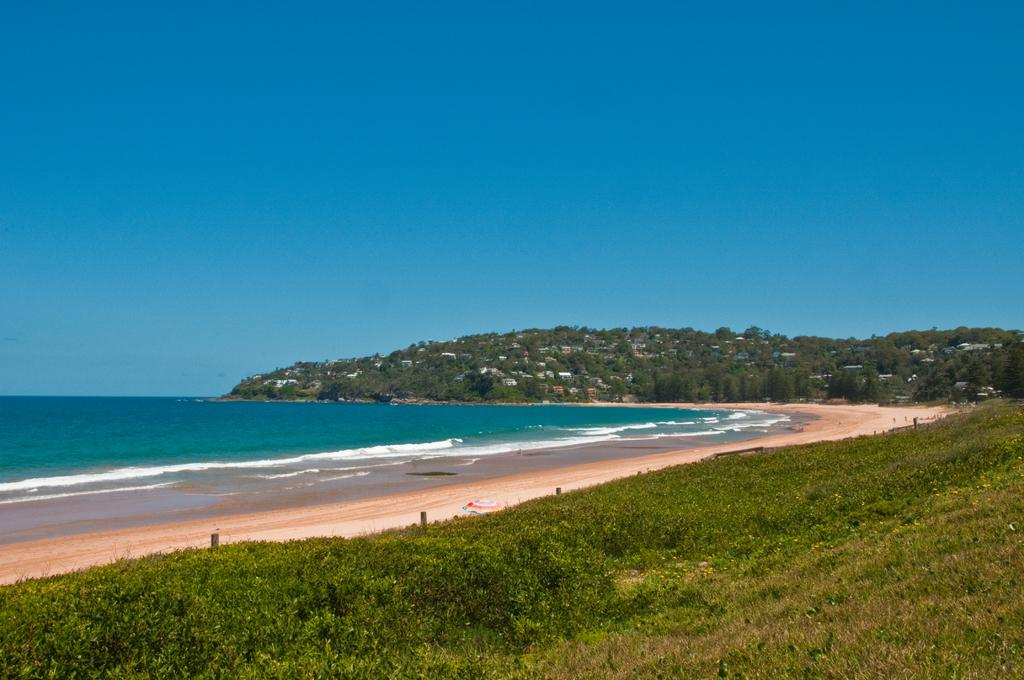What type of vegetation is in the foreground of the image? There are grasses and plants in the foreground of the image. What type of location is depicted in the image? The image depicts a beach. What can be seen in the background of the image? There is sea, trees, and buildings visible in the background of the image. What is the condition of the sky in the image? The sky is clear in the image. Can you hear the person coughing in the image? There is no sound or audio in the image, so it is not possible to hear anyone coughing. Is there a bridge visible in the image? There is no bridge present in the image; it depicts a beach with sea, trees, and buildings in the background. 